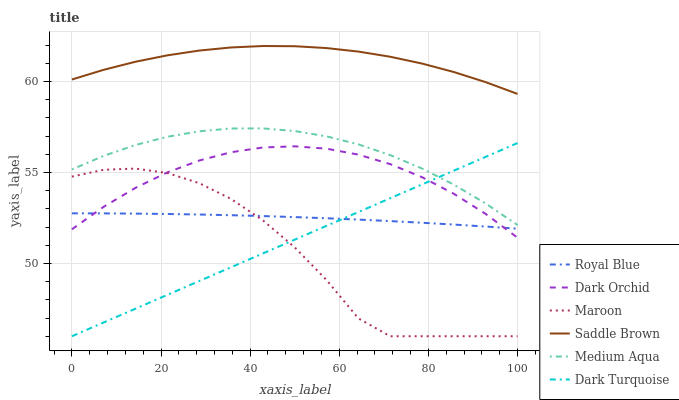Does Maroon have the minimum area under the curve?
Answer yes or no. Yes. Does Saddle Brown have the maximum area under the curve?
Answer yes or no. Yes. Does Royal Blue have the minimum area under the curve?
Answer yes or no. No. Does Royal Blue have the maximum area under the curve?
Answer yes or no. No. Is Dark Turquoise the smoothest?
Answer yes or no. Yes. Is Maroon the roughest?
Answer yes or no. Yes. Is Royal Blue the smoothest?
Answer yes or no. No. Is Royal Blue the roughest?
Answer yes or no. No. Does Royal Blue have the lowest value?
Answer yes or no. No. Does Saddle Brown have the highest value?
Answer yes or no. Yes. Does Maroon have the highest value?
Answer yes or no. No. Is Royal Blue less than Medium Aqua?
Answer yes or no. Yes. Is Saddle Brown greater than Dark Turquoise?
Answer yes or no. Yes. Does Medium Aqua intersect Dark Turquoise?
Answer yes or no. Yes. Is Medium Aqua less than Dark Turquoise?
Answer yes or no. No. Is Medium Aqua greater than Dark Turquoise?
Answer yes or no. No. Does Royal Blue intersect Medium Aqua?
Answer yes or no. No. 